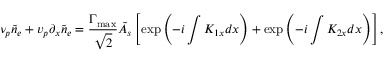Convert formula to latex. <formula><loc_0><loc_0><loc_500><loc_500>\nu _ { p } \tilde { n } _ { e } + v _ { p } \partial _ { x } \tilde { n } _ { e } = \frac { \Gamma _ { \max } } { \sqrt { 2 } } \tilde { A } _ { s } \left [ \exp \left ( - i \int K _ { 1 x } d x \right ) + \exp \left ( - i \int K _ { 2 x } d x \right ) \right ] ,</formula> 